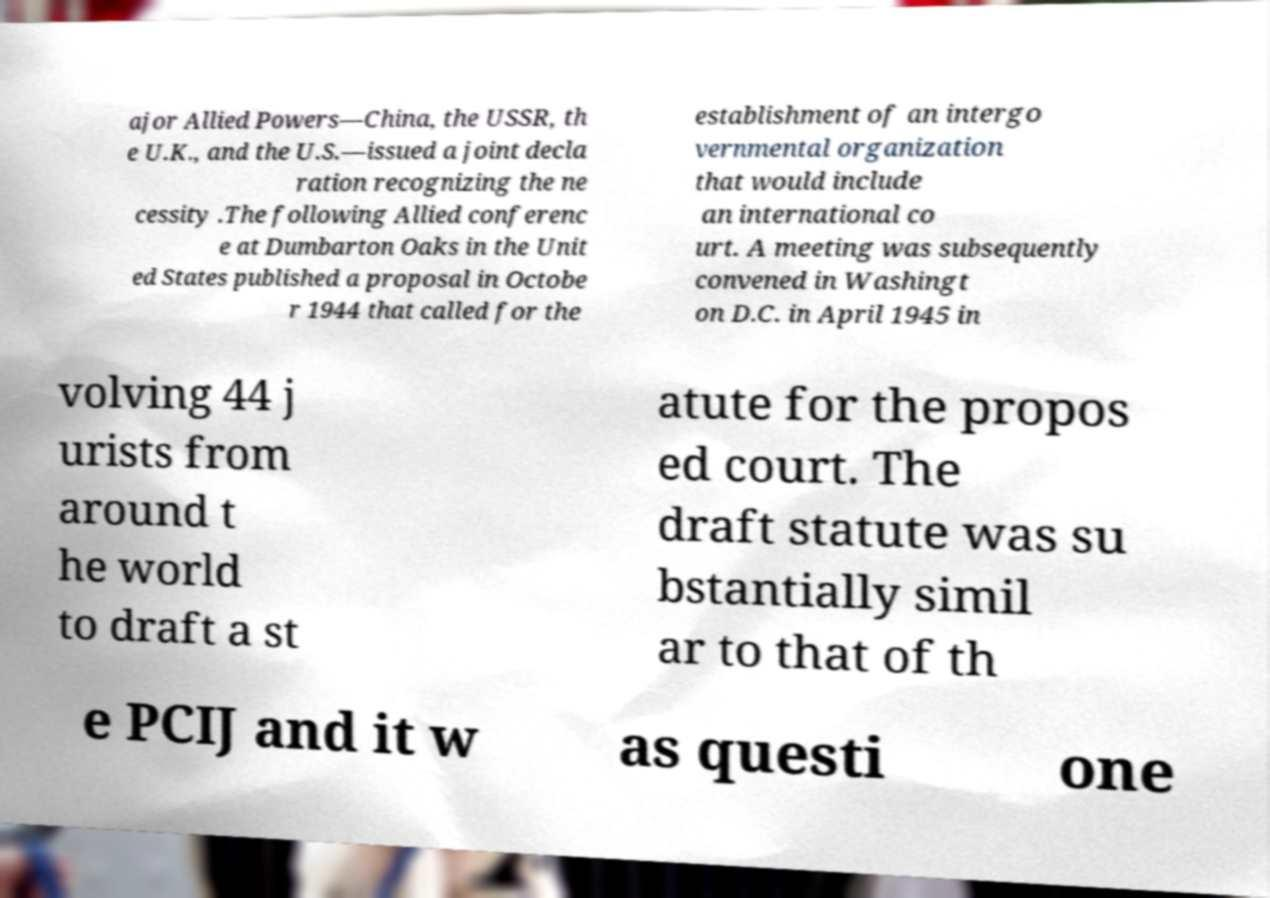Please read and relay the text visible in this image. What does it say? ajor Allied Powers—China, the USSR, th e U.K., and the U.S.—issued a joint decla ration recognizing the ne cessity .The following Allied conferenc e at Dumbarton Oaks in the Unit ed States published a proposal in Octobe r 1944 that called for the establishment of an intergo vernmental organization that would include an international co urt. A meeting was subsequently convened in Washingt on D.C. in April 1945 in volving 44 j urists from around t he world to draft a st atute for the propos ed court. The draft statute was su bstantially simil ar to that of th e PCIJ and it w as questi one 